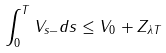Convert formula to latex. <formula><loc_0><loc_0><loc_500><loc_500>\int _ { 0 } ^ { T } V _ { s - } d s \leq V _ { 0 } + Z _ { \lambda T }</formula> 